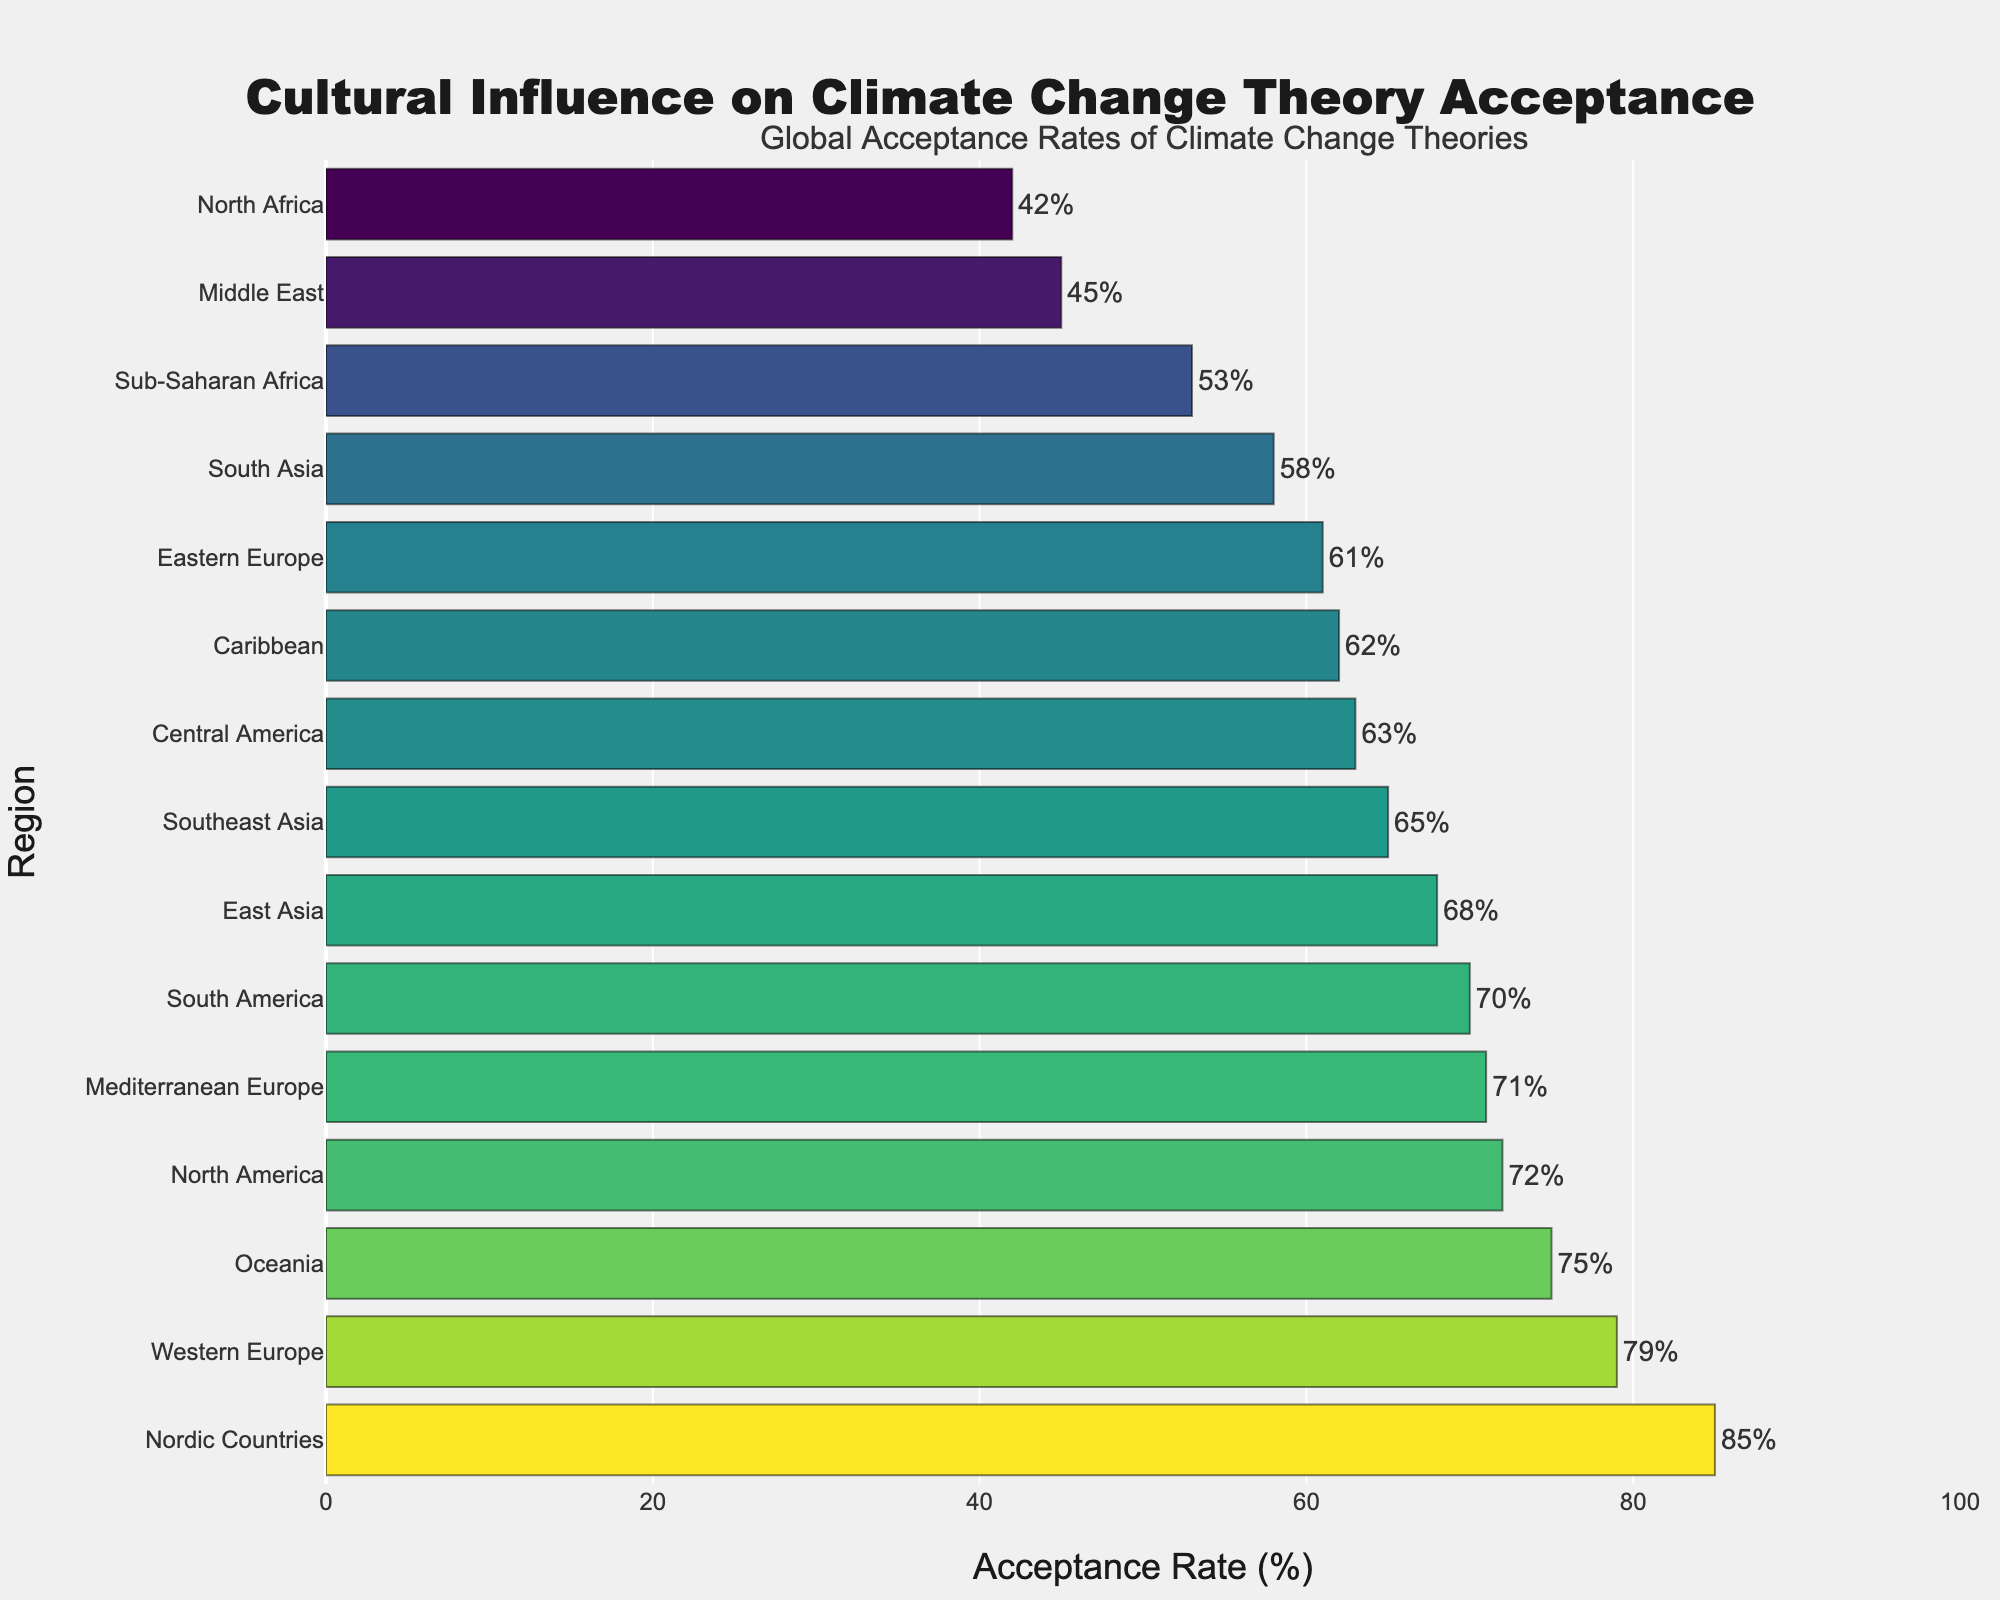Which region has the highest acceptance rate of climate change theories? The region with the highest bar indicates the highest acceptance rate. Looking at the plot, Nordic Countries has the tallest bar at 85%.
Answer: Nordic Countries What's the lowest acceptance rate of climate change theories? The region with the shortest bar has the lowest acceptance rate. The bar for North Africa is the shortest, showing an acceptance rate of 42%.
Answer: North Africa Compare the acceptance rates between East Asia and South Asia. Which is higher and by how much? East Asia has an acceptance rate of 68%, and South Asia has an acceptance rate of 58%. The difference is 68% - 58% = 10%.
Answer: East Asia by 10% What's the average acceptance rate across all regions? Sum all acceptance rates and then divide by the number of regions. Sum = 72+79+61+68+65+58+45+42+53+70+63+75+85+71+62 = 969. There are 15 regions. Average = 969 / 15 ≈ 64.6%.
Answer: 64.6% List all regions with an acceptance rate higher than 70%. Identify and select all regions with bars extending beyond the 70% mark. Nordic Countries (85%), Western Europe (79%), Oceania (75%), North America (72%), Mediterranean Europe (71%), South America (70%).
Answer: Nordic Countries, Western Europe, Oceania, North America, Mediterranean Europe, South America Which region has an acceptance rate closest to the global average acceptance rate? First, calculate the global average (64.6%). Then, find the region with the acceptance rate closest to this value. Central America has an acceptance rate of 63%, which is the closest to 64.6%.
Answer: Central America How many regions have an acceptance rate below 60%? Count the number of bars representing acceptance rates below the 60% mark. There are 6 regions: Eastern Europe (61%), Southeast Asia (65%), South Asia (58%), Middle East (45%), North Africa (42%), and Sub-Saharan Africa (53%).
Answer: 6 What is the combined acceptance rate of the regions in Asia (East Asia, Southeast Asia, South Asia)? Add the acceptance rates of the regions within Asia: East Asia (68%), Southeast Asia (65%), South Asia (58%). Combined acceptance rate = 68 + 65 + 58 = 191.
Answer: 191 Is there a region in Africa with an acceptance rate higher than 50%? Check the acceptance rates for all the regions in Africa. North Africa (42%) and Sub-Saharan Africa (53%). Sub-Saharan Africa is higher than 50%.
Answer: Sub-Saharan Africa 